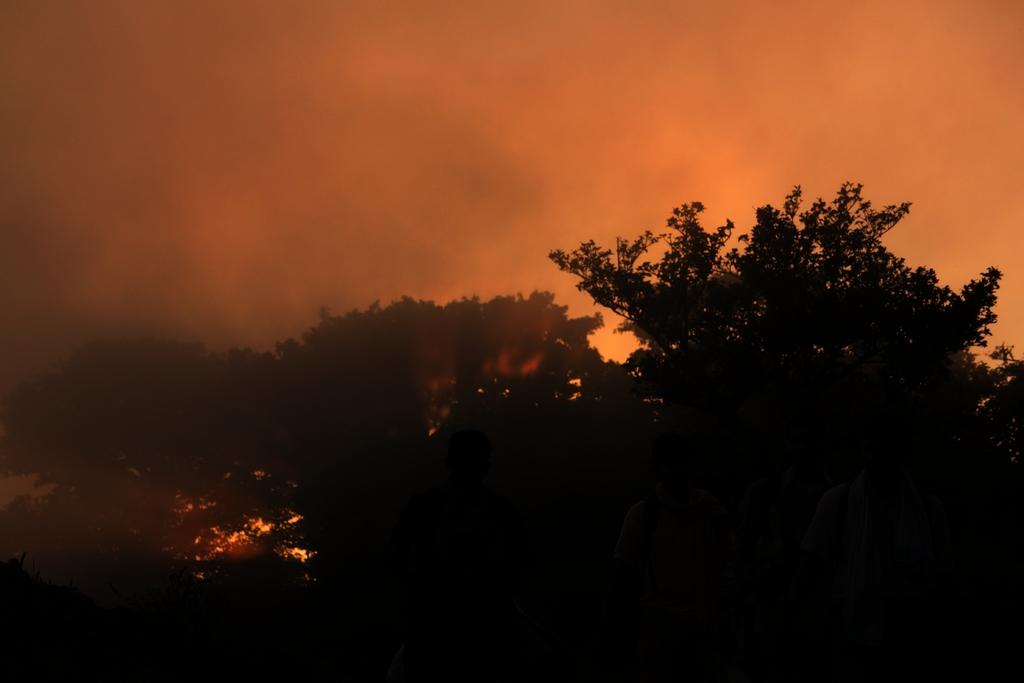What is the overall lighting condition in the image? The image is dark. What type of natural elements can be seen in the image? There are trees in the image. What part of the natural environment is visible in the background of the image? There is sky visible in the background of the image. What type of rhythm can be heard in the image? There is no sound or rhythm present in the image, as it is a still photograph. 